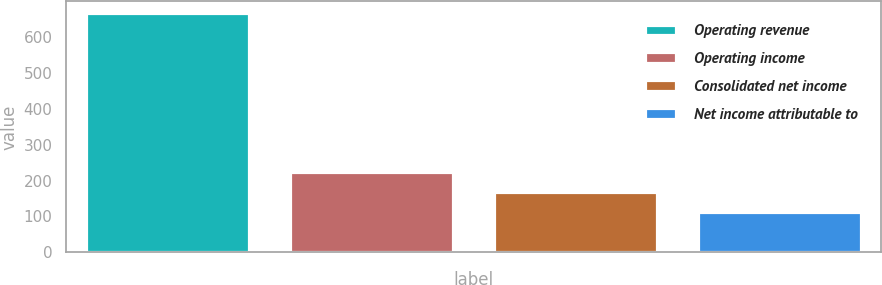Convert chart. <chart><loc_0><loc_0><loc_500><loc_500><bar_chart><fcel>Operating revenue<fcel>Operating income<fcel>Consolidated net income<fcel>Net income attributable to<nl><fcel>666.3<fcel>222.78<fcel>167.34<fcel>111.9<nl></chart> 